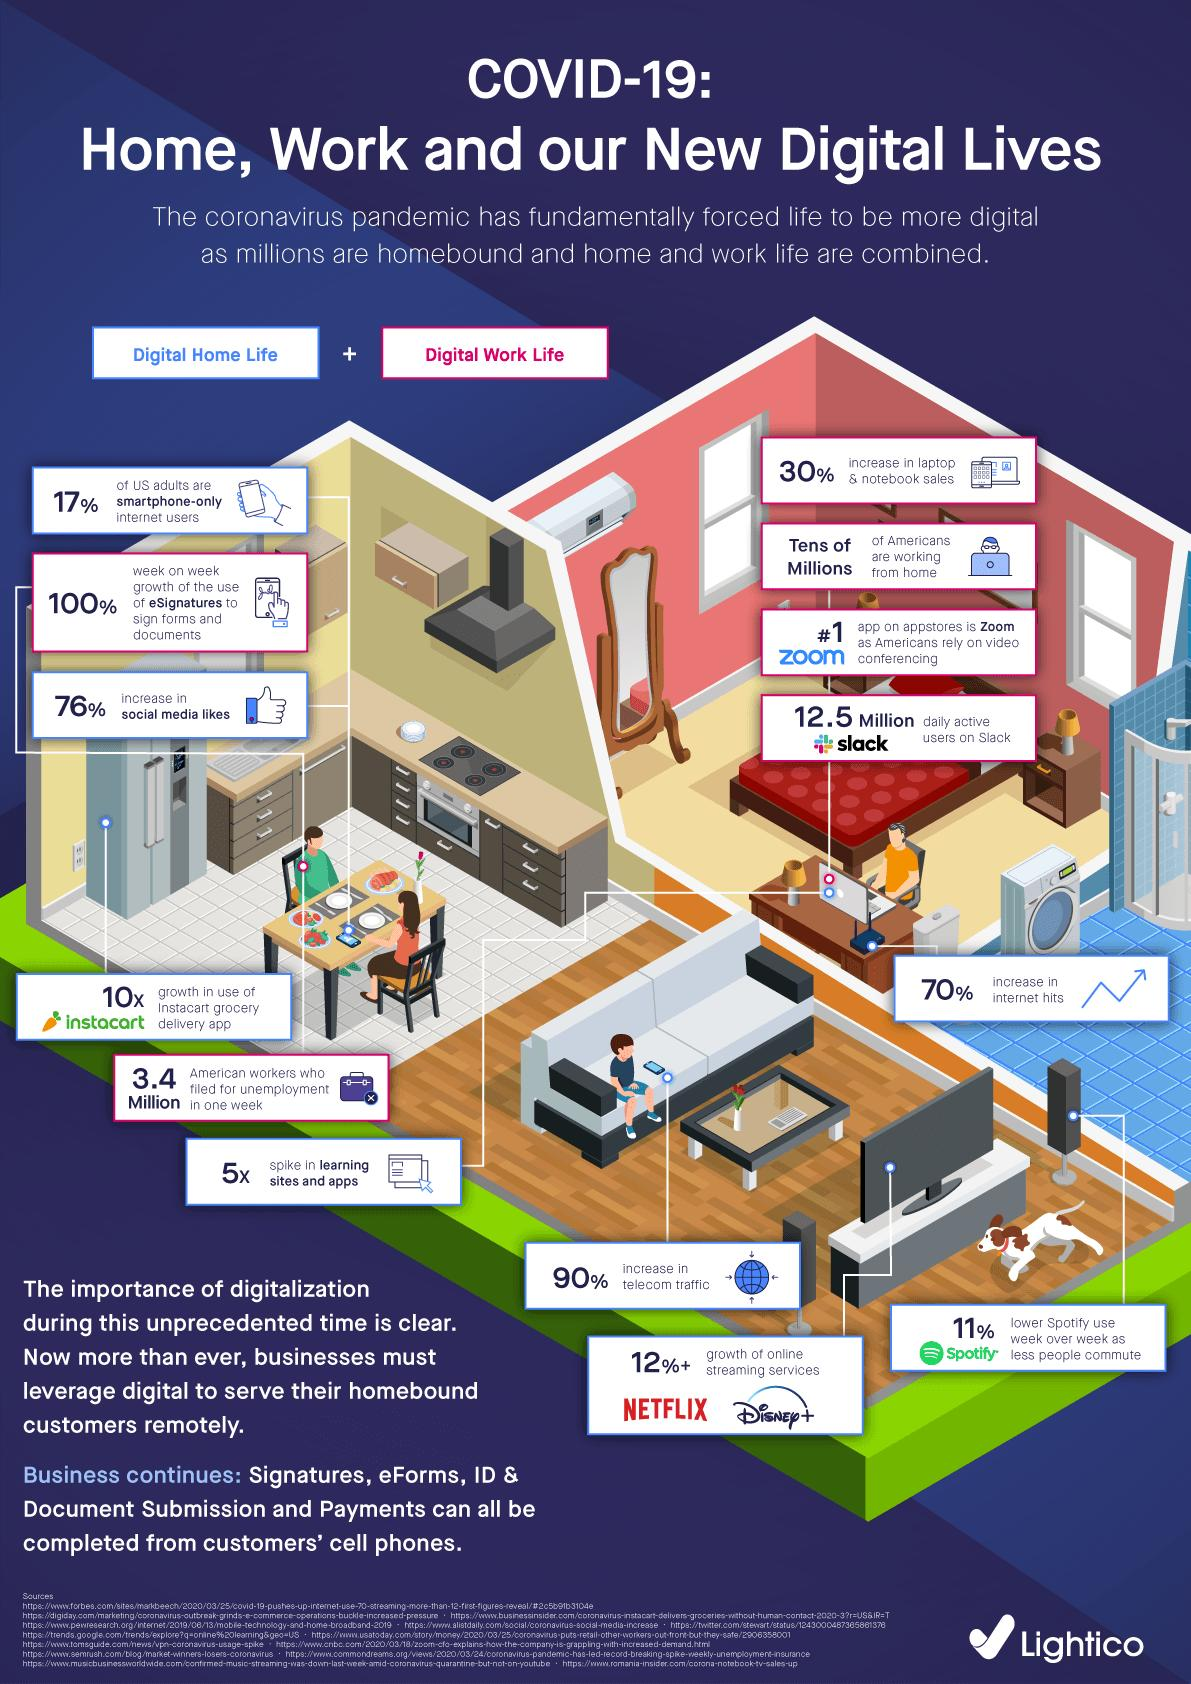Highlight a few significant elements in this photo. The telecom traffic has increased by 90% due to the COVID-19 impact. According to recent data, over 3.4 million American workers have filed for unemployment benefits due to the impact of COVID-19, reflecting the significant economic challenges faced by individuals and businesses during the pandemic. According to recent data, the percentage increase in online streaming services due to the COVID-19 pandemic is estimated to be 12%. Tens of millions of Americans have been working from home as a result of the COVID-19 outbreak. The sales of laptops and notebooks have increased by 30% due to the COVID-19 pandemic. 